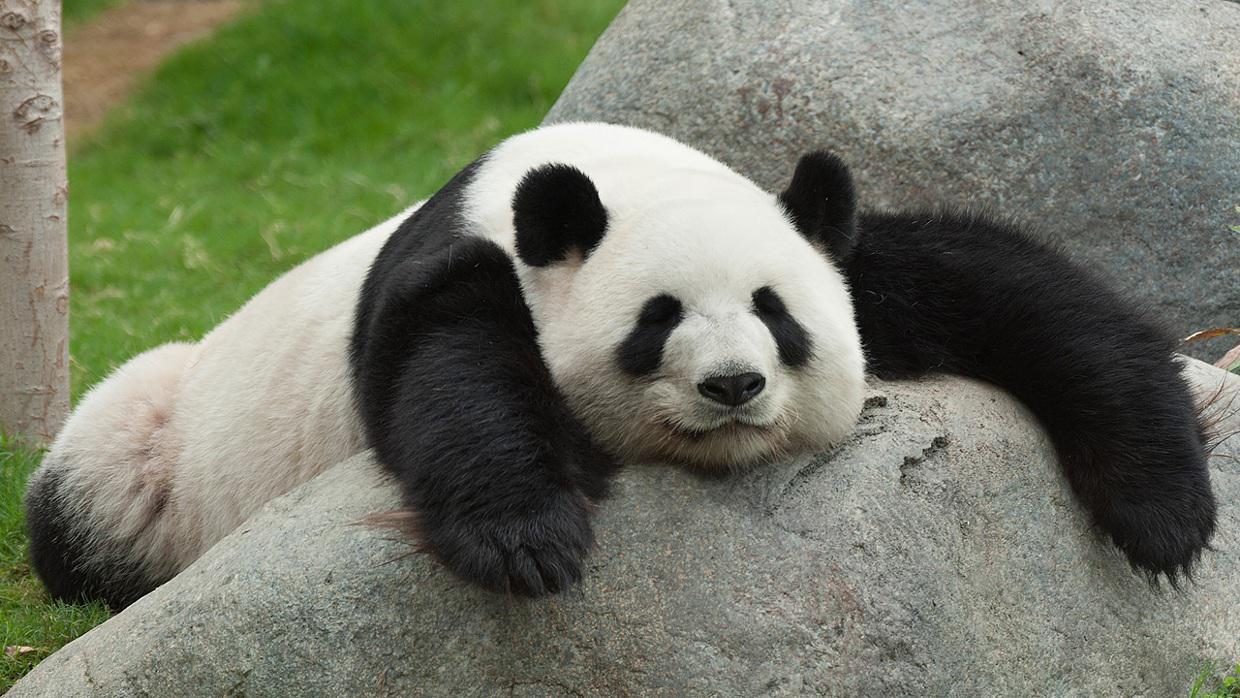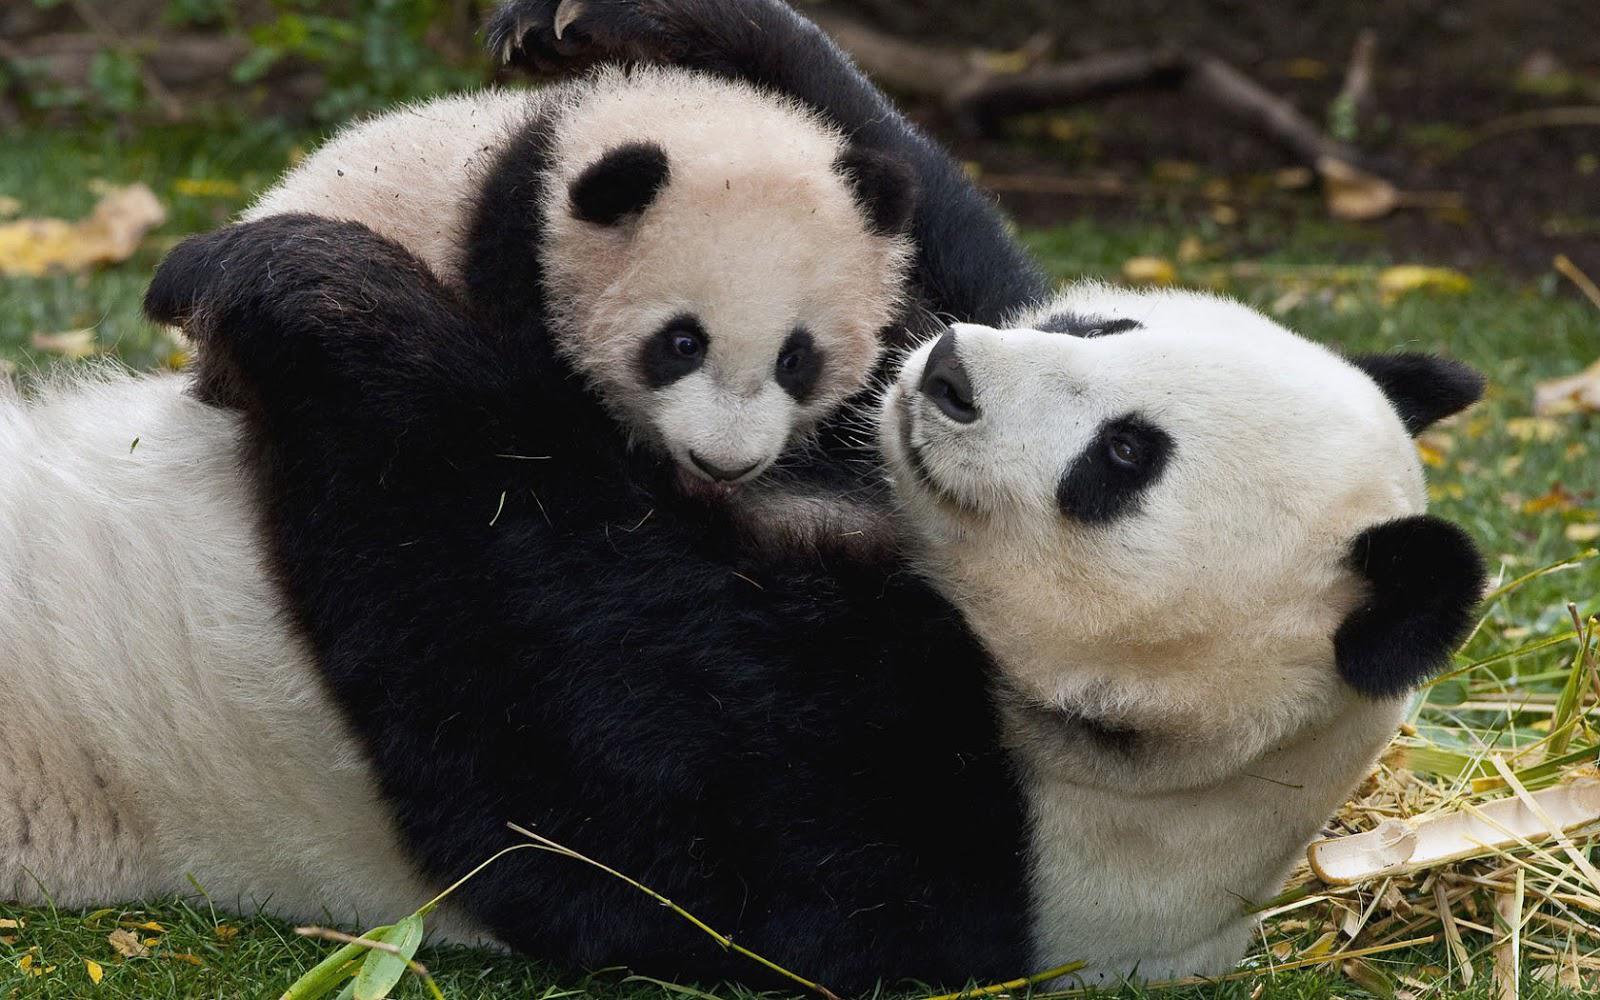The first image is the image on the left, the second image is the image on the right. For the images displayed, is the sentence "A baby panda is resting on its mother's chest" factually correct? Answer yes or no. Yes. 